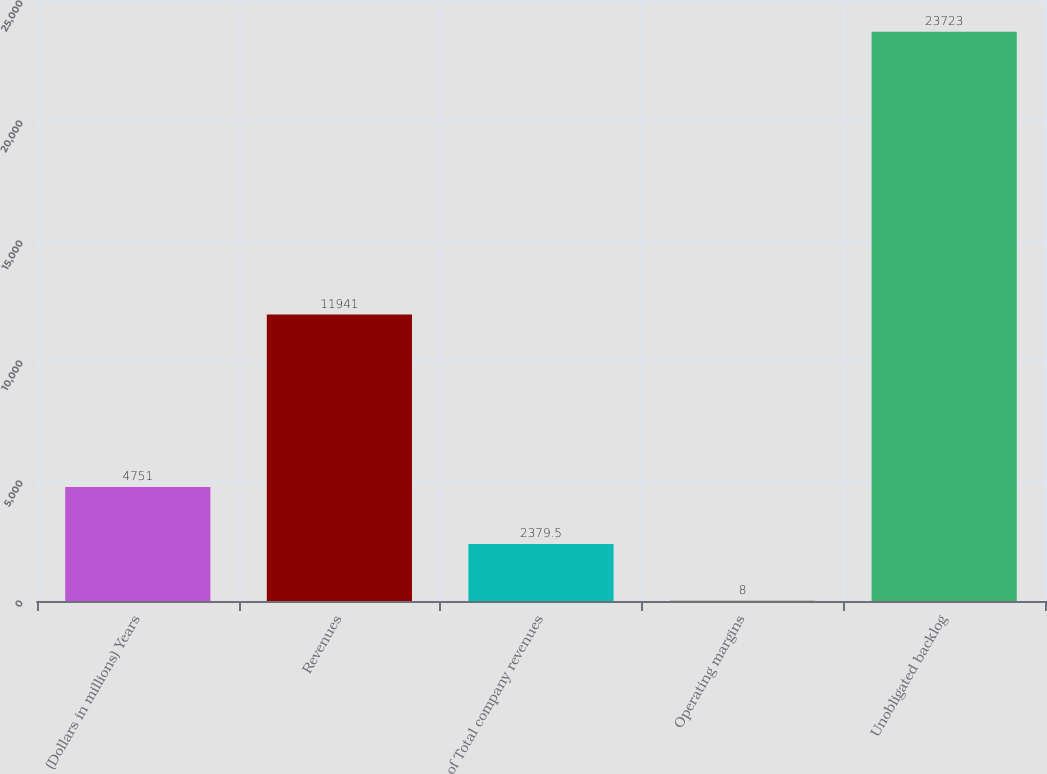Convert chart. <chart><loc_0><loc_0><loc_500><loc_500><bar_chart><fcel>(Dollars in millions) Years<fcel>Revenues<fcel>of Total company revenues<fcel>Operating margins<fcel>Unobligated backlog<nl><fcel>4751<fcel>11941<fcel>2379.5<fcel>8<fcel>23723<nl></chart> 